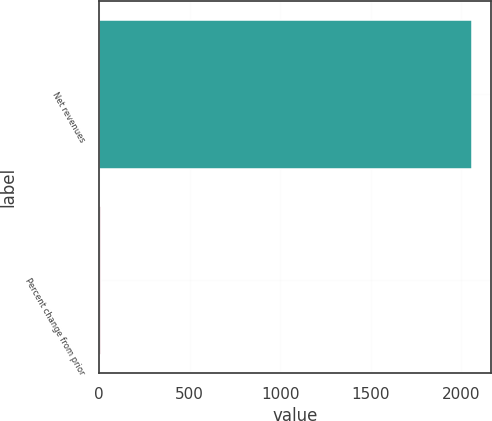<chart> <loc_0><loc_0><loc_500><loc_500><bar_chart><fcel>Net revenues<fcel>Percent change from prior<nl><fcel>2061<fcel>11<nl></chart> 